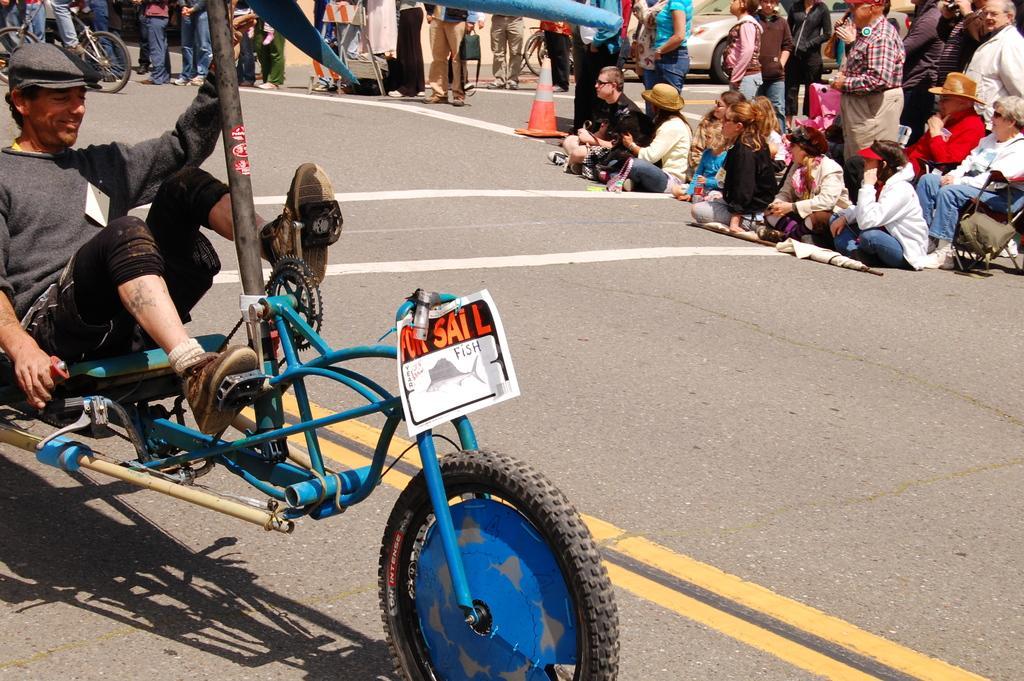Can you describe this image briefly? In this picture there is a person sitting on a vehicle and placed his legs on the pedals in front of him and there are few audience in the background. 